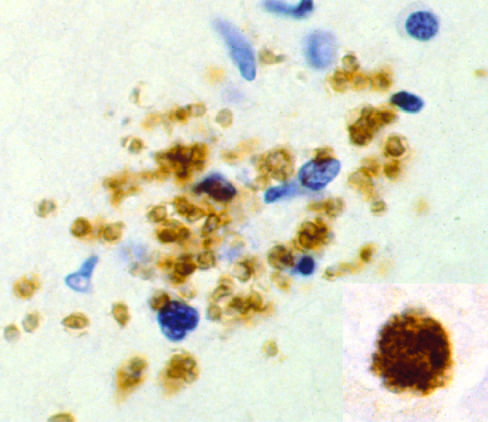re this condition present as a pseudocyst, again highlighted by immunohistochemical staining?
Answer the question using a single word or phrase. No 